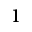<formula> <loc_0><loc_0><loc_500><loc_500>_ { 1 }</formula> 